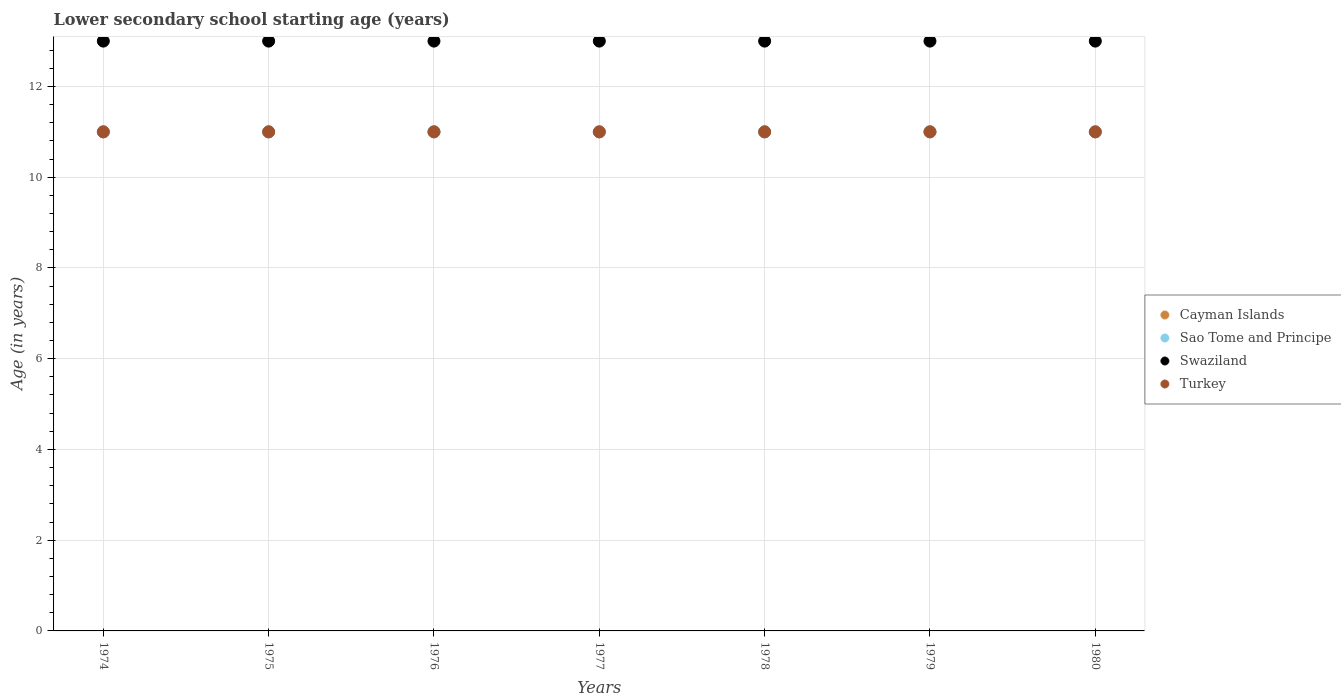Across all years, what is the maximum lower secondary school starting age of children in Swaziland?
Your answer should be very brief. 13. Across all years, what is the minimum lower secondary school starting age of children in Swaziland?
Keep it short and to the point. 13. In which year was the lower secondary school starting age of children in Turkey maximum?
Offer a very short reply. 1974. In which year was the lower secondary school starting age of children in Sao Tome and Principe minimum?
Offer a very short reply. 1974. What is the total lower secondary school starting age of children in Swaziland in the graph?
Make the answer very short. 91. In the year 1979, what is the difference between the lower secondary school starting age of children in Cayman Islands and lower secondary school starting age of children in Turkey?
Provide a short and direct response. 0. Is the lower secondary school starting age of children in Swaziland in 1974 less than that in 1977?
Provide a short and direct response. No. What is the difference between the highest and the second highest lower secondary school starting age of children in Sao Tome and Principe?
Provide a succinct answer. 0. In how many years, is the lower secondary school starting age of children in Swaziland greater than the average lower secondary school starting age of children in Swaziland taken over all years?
Your answer should be compact. 0. Does the lower secondary school starting age of children in Cayman Islands monotonically increase over the years?
Provide a short and direct response. No. Is the lower secondary school starting age of children in Turkey strictly greater than the lower secondary school starting age of children in Swaziland over the years?
Keep it short and to the point. No. Is the lower secondary school starting age of children in Sao Tome and Principe strictly less than the lower secondary school starting age of children in Cayman Islands over the years?
Make the answer very short. No. Does the graph contain any zero values?
Your answer should be compact. No. Does the graph contain grids?
Your answer should be compact. Yes. Where does the legend appear in the graph?
Offer a very short reply. Center right. How many legend labels are there?
Provide a short and direct response. 4. What is the title of the graph?
Keep it short and to the point. Lower secondary school starting age (years). What is the label or title of the Y-axis?
Offer a terse response. Age (in years). What is the Age (in years) of Cayman Islands in 1974?
Make the answer very short. 11. What is the Age (in years) in Sao Tome and Principe in 1974?
Provide a short and direct response. 11. What is the Age (in years) in Swaziland in 1974?
Your answer should be very brief. 13. What is the Age (in years) in Cayman Islands in 1975?
Ensure brevity in your answer.  11. What is the Age (in years) of Sao Tome and Principe in 1975?
Your response must be concise. 11. What is the Age (in years) of Sao Tome and Principe in 1976?
Ensure brevity in your answer.  11. What is the Age (in years) in Turkey in 1976?
Provide a short and direct response. 11. What is the Age (in years) of Cayman Islands in 1977?
Keep it short and to the point. 11. What is the Age (in years) of Turkey in 1977?
Offer a terse response. 11. What is the Age (in years) of Turkey in 1978?
Your answer should be very brief. 11. What is the Age (in years) in Cayman Islands in 1979?
Provide a short and direct response. 11. What is the Age (in years) of Sao Tome and Principe in 1979?
Your answer should be very brief. 11. What is the Age (in years) in Cayman Islands in 1980?
Ensure brevity in your answer.  11. What is the Age (in years) in Turkey in 1980?
Keep it short and to the point. 11. Across all years, what is the maximum Age (in years) in Cayman Islands?
Make the answer very short. 11. Across all years, what is the maximum Age (in years) in Turkey?
Provide a short and direct response. 11. Across all years, what is the minimum Age (in years) in Cayman Islands?
Keep it short and to the point. 11. Across all years, what is the minimum Age (in years) in Turkey?
Ensure brevity in your answer.  11. What is the total Age (in years) of Swaziland in the graph?
Provide a short and direct response. 91. What is the difference between the Age (in years) of Cayman Islands in 1974 and that in 1975?
Offer a very short reply. 0. What is the difference between the Age (in years) in Swaziland in 1974 and that in 1975?
Provide a succinct answer. 0. What is the difference between the Age (in years) in Turkey in 1974 and that in 1975?
Keep it short and to the point. 0. What is the difference between the Age (in years) in Sao Tome and Principe in 1974 and that in 1977?
Keep it short and to the point. 0. What is the difference between the Age (in years) in Swaziland in 1974 and that in 1977?
Provide a succinct answer. 0. What is the difference between the Age (in years) in Turkey in 1974 and that in 1977?
Your answer should be very brief. 0. What is the difference between the Age (in years) in Cayman Islands in 1974 and that in 1978?
Your answer should be compact. 0. What is the difference between the Age (in years) of Sao Tome and Principe in 1974 and that in 1978?
Ensure brevity in your answer.  0. What is the difference between the Age (in years) in Turkey in 1974 and that in 1978?
Make the answer very short. 0. What is the difference between the Age (in years) of Cayman Islands in 1974 and that in 1979?
Your response must be concise. 0. What is the difference between the Age (in years) of Sao Tome and Principe in 1974 and that in 1979?
Offer a very short reply. 0. What is the difference between the Age (in years) in Swaziland in 1974 and that in 1979?
Give a very brief answer. 0. What is the difference between the Age (in years) of Turkey in 1974 and that in 1979?
Provide a succinct answer. 0. What is the difference between the Age (in years) of Cayman Islands in 1974 and that in 1980?
Provide a succinct answer. 0. What is the difference between the Age (in years) of Swaziland in 1974 and that in 1980?
Offer a very short reply. 0. What is the difference between the Age (in years) in Turkey in 1974 and that in 1980?
Offer a terse response. 0. What is the difference between the Age (in years) in Cayman Islands in 1975 and that in 1976?
Give a very brief answer. 0. What is the difference between the Age (in years) of Sao Tome and Principe in 1975 and that in 1976?
Offer a very short reply. 0. What is the difference between the Age (in years) of Cayman Islands in 1975 and that in 1977?
Provide a succinct answer. 0. What is the difference between the Age (in years) in Sao Tome and Principe in 1975 and that in 1977?
Make the answer very short. 0. What is the difference between the Age (in years) in Swaziland in 1975 and that in 1977?
Offer a terse response. 0. What is the difference between the Age (in years) of Turkey in 1975 and that in 1977?
Ensure brevity in your answer.  0. What is the difference between the Age (in years) in Cayman Islands in 1975 and that in 1978?
Make the answer very short. 0. What is the difference between the Age (in years) of Sao Tome and Principe in 1975 and that in 1978?
Your answer should be compact. 0. What is the difference between the Age (in years) of Swaziland in 1975 and that in 1978?
Make the answer very short. 0. What is the difference between the Age (in years) in Turkey in 1975 and that in 1979?
Ensure brevity in your answer.  0. What is the difference between the Age (in years) in Cayman Islands in 1976 and that in 1977?
Keep it short and to the point. 0. What is the difference between the Age (in years) of Sao Tome and Principe in 1976 and that in 1977?
Your answer should be very brief. 0. What is the difference between the Age (in years) in Swaziland in 1976 and that in 1977?
Your answer should be compact. 0. What is the difference between the Age (in years) in Turkey in 1976 and that in 1978?
Offer a very short reply. 0. What is the difference between the Age (in years) in Swaziland in 1976 and that in 1979?
Provide a succinct answer. 0. What is the difference between the Age (in years) in Sao Tome and Principe in 1976 and that in 1980?
Your answer should be compact. 0. What is the difference between the Age (in years) in Turkey in 1976 and that in 1980?
Your response must be concise. 0. What is the difference between the Age (in years) of Sao Tome and Principe in 1977 and that in 1978?
Give a very brief answer. 0. What is the difference between the Age (in years) in Swaziland in 1977 and that in 1978?
Provide a short and direct response. 0. What is the difference between the Age (in years) in Cayman Islands in 1977 and that in 1980?
Offer a terse response. 0. What is the difference between the Age (in years) of Swaziland in 1977 and that in 1980?
Provide a succinct answer. 0. What is the difference between the Age (in years) in Sao Tome and Principe in 1978 and that in 1979?
Offer a terse response. 0. What is the difference between the Age (in years) in Swaziland in 1978 and that in 1980?
Offer a terse response. 0. What is the difference between the Age (in years) in Cayman Islands in 1979 and that in 1980?
Keep it short and to the point. 0. What is the difference between the Age (in years) of Sao Tome and Principe in 1979 and that in 1980?
Your answer should be compact. 0. What is the difference between the Age (in years) of Cayman Islands in 1974 and the Age (in years) of Swaziland in 1975?
Offer a terse response. -2. What is the difference between the Age (in years) in Cayman Islands in 1974 and the Age (in years) in Turkey in 1975?
Provide a short and direct response. 0. What is the difference between the Age (in years) in Swaziland in 1974 and the Age (in years) in Turkey in 1975?
Provide a succinct answer. 2. What is the difference between the Age (in years) of Cayman Islands in 1974 and the Age (in years) of Sao Tome and Principe in 1976?
Provide a short and direct response. 0. What is the difference between the Age (in years) of Cayman Islands in 1974 and the Age (in years) of Swaziland in 1976?
Give a very brief answer. -2. What is the difference between the Age (in years) of Sao Tome and Principe in 1974 and the Age (in years) of Turkey in 1976?
Offer a very short reply. 0. What is the difference between the Age (in years) of Swaziland in 1974 and the Age (in years) of Turkey in 1976?
Provide a succinct answer. 2. What is the difference between the Age (in years) in Cayman Islands in 1974 and the Age (in years) in Sao Tome and Principe in 1977?
Your answer should be compact. 0. What is the difference between the Age (in years) in Cayman Islands in 1974 and the Age (in years) in Turkey in 1977?
Offer a very short reply. 0. What is the difference between the Age (in years) of Sao Tome and Principe in 1974 and the Age (in years) of Swaziland in 1977?
Your answer should be very brief. -2. What is the difference between the Age (in years) of Sao Tome and Principe in 1974 and the Age (in years) of Turkey in 1977?
Your answer should be compact. 0. What is the difference between the Age (in years) in Swaziland in 1974 and the Age (in years) in Turkey in 1977?
Make the answer very short. 2. What is the difference between the Age (in years) of Cayman Islands in 1974 and the Age (in years) of Sao Tome and Principe in 1978?
Provide a short and direct response. 0. What is the difference between the Age (in years) in Cayman Islands in 1974 and the Age (in years) in Turkey in 1978?
Your response must be concise. 0. What is the difference between the Age (in years) of Sao Tome and Principe in 1974 and the Age (in years) of Swaziland in 1978?
Offer a very short reply. -2. What is the difference between the Age (in years) of Swaziland in 1974 and the Age (in years) of Turkey in 1978?
Ensure brevity in your answer.  2. What is the difference between the Age (in years) of Cayman Islands in 1974 and the Age (in years) of Sao Tome and Principe in 1979?
Keep it short and to the point. 0. What is the difference between the Age (in years) of Sao Tome and Principe in 1974 and the Age (in years) of Swaziland in 1979?
Ensure brevity in your answer.  -2. What is the difference between the Age (in years) of Sao Tome and Principe in 1974 and the Age (in years) of Turkey in 1979?
Offer a very short reply. 0. What is the difference between the Age (in years) of Swaziland in 1974 and the Age (in years) of Turkey in 1979?
Keep it short and to the point. 2. What is the difference between the Age (in years) in Sao Tome and Principe in 1974 and the Age (in years) in Turkey in 1980?
Offer a very short reply. 0. What is the difference between the Age (in years) in Swaziland in 1974 and the Age (in years) in Turkey in 1980?
Make the answer very short. 2. What is the difference between the Age (in years) of Cayman Islands in 1975 and the Age (in years) of Swaziland in 1976?
Give a very brief answer. -2. What is the difference between the Age (in years) of Sao Tome and Principe in 1975 and the Age (in years) of Swaziland in 1976?
Provide a short and direct response. -2. What is the difference between the Age (in years) of Sao Tome and Principe in 1975 and the Age (in years) of Turkey in 1976?
Your response must be concise. 0. What is the difference between the Age (in years) of Swaziland in 1975 and the Age (in years) of Turkey in 1977?
Give a very brief answer. 2. What is the difference between the Age (in years) in Cayman Islands in 1975 and the Age (in years) in Sao Tome and Principe in 1978?
Your response must be concise. 0. What is the difference between the Age (in years) of Cayman Islands in 1975 and the Age (in years) of Turkey in 1978?
Provide a succinct answer. 0. What is the difference between the Age (in years) in Sao Tome and Principe in 1975 and the Age (in years) in Swaziland in 1978?
Ensure brevity in your answer.  -2. What is the difference between the Age (in years) in Sao Tome and Principe in 1975 and the Age (in years) in Swaziland in 1979?
Make the answer very short. -2. What is the difference between the Age (in years) in Sao Tome and Principe in 1975 and the Age (in years) in Turkey in 1980?
Make the answer very short. 0. What is the difference between the Age (in years) in Cayman Islands in 1976 and the Age (in years) in Swaziland in 1977?
Make the answer very short. -2. What is the difference between the Age (in years) of Cayman Islands in 1976 and the Age (in years) of Turkey in 1977?
Make the answer very short. 0. What is the difference between the Age (in years) in Sao Tome and Principe in 1976 and the Age (in years) in Swaziland in 1977?
Your answer should be very brief. -2. What is the difference between the Age (in years) in Cayman Islands in 1976 and the Age (in years) in Sao Tome and Principe in 1978?
Provide a short and direct response. 0. What is the difference between the Age (in years) of Sao Tome and Principe in 1976 and the Age (in years) of Turkey in 1978?
Offer a terse response. 0. What is the difference between the Age (in years) of Cayman Islands in 1976 and the Age (in years) of Swaziland in 1979?
Provide a succinct answer. -2. What is the difference between the Age (in years) of Cayman Islands in 1976 and the Age (in years) of Turkey in 1979?
Provide a succinct answer. 0. What is the difference between the Age (in years) of Swaziland in 1976 and the Age (in years) of Turkey in 1979?
Provide a succinct answer. 2. What is the difference between the Age (in years) in Cayman Islands in 1976 and the Age (in years) in Swaziland in 1980?
Your answer should be compact. -2. What is the difference between the Age (in years) in Cayman Islands in 1976 and the Age (in years) in Turkey in 1980?
Ensure brevity in your answer.  0. What is the difference between the Age (in years) of Sao Tome and Principe in 1976 and the Age (in years) of Turkey in 1980?
Your response must be concise. 0. What is the difference between the Age (in years) in Cayman Islands in 1977 and the Age (in years) in Sao Tome and Principe in 1978?
Give a very brief answer. 0. What is the difference between the Age (in years) of Cayman Islands in 1977 and the Age (in years) of Turkey in 1978?
Give a very brief answer. 0. What is the difference between the Age (in years) of Sao Tome and Principe in 1977 and the Age (in years) of Swaziland in 1978?
Make the answer very short. -2. What is the difference between the Age (in years) in Cayman Islands in 1977 and the Age (in years) in Sao Tome and Principe in 1979?
Give a very brief answer. 0. What is the difference between the Age (in years) of Cayman Islands in 1977 and the Age (in years) of Swaziland in 1979?
Your answer should be very brief. -2. What is the difference between the Age (in years) of Sao Tome and Principe in 1977 and the Age (in years) of Turkey in 1979?
Your response must be concise. 0. What is the difference between the Age (in years) in Swaziland in 1977 and the Age (in years) in Turkey in 1979?
Your answer should be compact. 2. What is the difference between the Age (in years) in Cayman Islands in 1977 and the Age (in years) in Swaziland in 1980?
Provide a succinct answer. -2. What is the difference between the Age (in years) of Cayman Islands in 1977 and the Age (in years) of Turkey in 1980?
Ensure brevity in your answer.  0. What is the difference between the Age (in years) of Sao Tome and Principe in 1977 and the Age (in years) of Swaziland in 1980?
Provide a short and direct response. -2. What is the difference between the Age (in years) in Sao Tome and Principe in 1977 and the Age (in years) in Turkey in 1980?
Provide a short and direct response. 0. What is the difference between the Age (in years) in Swaziland in 1977 and the Age (in years) in Turkey in 1980?
Ensure brevity in your answer.  2. What is the difference between the Age (in years) of Cayman Islands in 1978 and the Age (in years) of Swaziland in 1979?
Your answer should be compact. -2. What is the difference between the Age (in years) in Cayman Islands in 1978 and the Age (in years) in Turkey in 1979?
Your response must be concise. 0. What is the difference between the Age (in years) in Swaziland in 1978 and the Age (in years) in Turkey in 1979?
Provide a succinct answer. 2. What is the difference between the Age (in years) of Sao Tome and Principe in 1978 and the Age (in years) of Swaziland in 1980?
Your response must be concise. -2. What is the difference between the Age (in years) of Sao Tome and Principe in 1978 and the Age (in years) of Turkey in 1980?
Your answer should be very brief. 0. What is the difference between the Age (in years) in Cayman Islands in 1979 and the Age (in years) in Swaziland in 1980?
Offer a terse response. -2. What is the difference between the Age (in years) of Cayman Islands in 1979 and the Age (in years) of Turkey in 1980?
Keep it short and to the point. 0. What is the difference between the Age (in years) of Sao Tome and Principe in 1979 and the Age (in years) of Swaziland in 1980?
Provide a short and direct response. -2. What is the difference between the Age (in years) in Sao Tome and Principe in 1979 and the Age (in years) in Turkey in 1980?
Ensure brevity in your answer.  0. What is the difference between the Age (in years) of Swaziland in 1979 and the Age (in years) of Turkey in 1980?
Your answer should be compact. 2. What is the average Age (in years) in Swaziland per year?
Your answer should be very brief. 13. What is the average Age (in years) of Turkey per year?
Make the answer very short. 11. In the year 1974, what is the difference between the Age (in years) of Cayman Islands and Age (in years) of Turkey?
Your answer should be very brief. 0. In the year 1974, what is the difference between the Age (in years) of Sao Tome and Principe and Age (in years) of Swaziland?
Provide a short and direct response. -2. In the year 1974, what is the difference between the Age (in years) in Sao Tome and Principe and Age (in years) in Turkey?
Make the answer very short. 0. In the year 1975, what is the difference between the Age (in years) of Cayman Islands and Age (in years) of Sao Tome and Principe?
Offer a terse response. 0. In the year 1975, what is the difference between the Age (in years) of Cayman Islands and Age (in years) of Swaziland?
Keep it short and to the point. -2. In the year 1975, what is the difference between the Age (in years) in Sao Tome and Principe and Age (in years) in Swaziland?
Keep it short and to the point. -2. In the year 1975, what is the difference between the Age (in years) in Sao Tome and Principe and Age (in years) in Turkey?
Provide a succinct answer. 0. In the year 1975, what is the difference between the Age (in years) in Swaziland and Age (in years) in Turkey?
Give a very brief answer. 2. In the year 1976, what is the difference between the Age (in years) of Cayman Islands and Age (in years) of Sao Tome and Principe?
Offer a terse response. 0. In the year 1976, what is the difference between the Age (in years) in Cayman Islands and Age (in years) in Swaziland?
Keep it short and to the point. -2. In the year 1976, what is the difference between the Age (in years) of Sao Tome and Principe and Age (in years) of Swaziland?
Your response must be concise. -2. In the year 1977, what is the difference between the Age (in years) of Cayman Islands and Age (in years) of Sao Tome and Principe?
Offer a terse response. 0. In the year 1977, what is the difference between the Age (in years) of Cayman Islands and Age (in years) of Swaziland?
Keep it short and to the point. -2. In the year 1977, what is the difference between the Age (in years) in Cayman Islands and Age (in years) in Turkey?
Offer a terse response. 0. In the year 1977, what is the difference between the Age (in years) of Sao Tome and Principe and Age (in years) of Swaziland?
Your response must be concise. -2. In the year 1977, what is the difference between the Age (in years) in Sao Tome and Principe and Age (in years) in Turkey?
Ensure brevity in your answer.  0. In the year 1978, what is the difference between the Age (in years) of Cayman Islands and Age (in years) of Turkey?
Your answer should be very brief. 0. In the year 1978, what is the difference between the Age (in years) in Sao Tome and Principe and Age (in years) in Swaziland?
Ensure brevity in your answer.  -2. In the year 1978, what is the difference between the Age (in years) in Swaziland and Age (in years) in Turkey?
Offer a very short reply. 2. In the year 1979, what is the difference between the Age (in years) of Cayman Islands and Age (in years) of Swaziland?
Provide a succinct answer. -2. In the year 1979, what is the difference between the Age (in years) of Cayman Islands and Age (in years) of Turkey?
Offer a very short reply. 0. In the year 1979, what is the difference between the Age (in years) in Sao Tome and Principe and Age (in years) in Swaziland?
Keep it short and to the point. -2. In the year 1979, what is the difference between the Age (in years) of Sao Tome and Principe and Age (in years) of Turkey?
Give a very brief answer. 0. In the year 1979, what is the difference between the Age (in years) of Swaziland and Age (in years) of Turkey?
Provide a short and direct response. 2. In the year 1980, what is the difference between the Age (in years) of Cayman Islands and Age (in years) of Swaziland?
Your response must be concise. -2. In the year 1980, what is the difference between the Age (in years) of Cayman Islands and Age (in years) of Turkey?
Provide a succinct answer. 0. In the year 1980, what is the difference between the Age (in years) of Sao Tome and Principe and Age (in years) of Swaziland?
Your answer should be compact. -2. In the year 1980, what is the difference between the Age (in years) of Sao Tome and Principe and Age (in years) of Turkey?
Provide a succinct answer. 0. What is the ratio of the Age (in years) in Cayman Islands in 1974 to that in 1975?
Keep it short and to the point. 1. What is the ratio of the Age (in years) in Sao Tome and Principe in 1974 to that in 1975?
Provide a succinct answer. 1. What is the ratio of the Age (in years) of Swaziland in 1974 to that in 1975?
Your answer should be compact. 1. What is the ratio of the Age (in years) of Turkey in 1974 to that in 1975?
Make the answer very short. 1. What is the ratio of the Age (in years) of Cayman Islands in 1974 to that in 1977?
Your answer should be very brief. 1. What is the ratio of the Age (in years) of Swaziland in 1974 to that in 1977?
Offer a very short reply. 1. What is the ratio of the Age (in years) of Turkey in 1974 to that in 1978?
Your answer should be compact. 1. What is the ratio of the Age (in years) of Cayman Islands in 1974 to that in 1979?
Keep it short and to the point. 1. What is the ratio of the Age (in years) of Sao Tome and Principe in 1974 to that in 1979?
Ensure brevity in your answer.  1. What is the ratio of the Age (in years) of Turkey in 1974 to that in 1979?
Keep it short and to the point. 1. What is the ratio of the Age (in years) in Swaziland in 1974 to that in 1980?
Keep it short and to the point. 1. What is the ratio of the Age (in years) of Sao Tome and Principe in 1975 to that in 1976?
Make the answer very short. 1. What is the ratio of the Age (in years) of Turkey in 1975 to that in 1976?
Ensure brevity in your answer.  1. What is the ratio of the Age (in years) in Cayman Islands in 1975 to that in 1977?
Ensure brevity in your answer.  1. What is the ratio of the Age (in years) of Sao Tome and Principe in 1975 to that in 1977?
Provide a short and direct response. 1. What is the ratio of the Age (in years) in Swaziland in 1975 to that in 1977?
Give a very brief answer. 1. What is the ratio of the Age (in years) of Turkey in 1975 to that in 1977?
Provide a short and direct response. 1. What is the ratio of the Age (in years) in Turkey in 1975 to that in 1978?
Ensure brevity in your answer.  1. What is the ratio of the Age (in years) of Turkey in 1975 to that in 1979?
Offer a very short reply. 1. What is the ratio of the Age (in years) of Swaziland in 1975 to that in 1980?
Keep it short and to the point. 1. What is the ratio of the Age (in years) in Cayman Islands in 1976 to that in 1977?
Your response must be concise. 1. What is the ratio of the Age (in years) in Turkey in 1976 to that in 1977?
Your answer should be very brief. 1. What is the ratio of the Age (in years) in Swaziland in 1976 to that in 1978?
Your answer should be very brief. 1. What is the ratio of the Age (in years) of Cayman Islands in 1976 to that in 1979?
Provide a succinct answer. 1. What is the ratio of the Age (in years) of Turkey in 1976 to that in 1979?
Provide a succinct answer. 1. What is the ratio of the Age (in years) in Cayman Islands in 1976 to that in 1980?
Keep it short and to the point. 1. What is the ratio of the Age (in years) of Sao Tome and Principe in 1976 to that in 1980?
Provide a succinct answer. 1. What is the ratio of the Age (in years) in Swaziland in 1976 to that in 1980?
Provide a short and direct response. 1. What is the ratio of the Age (in years) in Turkey in 1976 to that in 1980?
Make the answer very short. 1. What is the ratio of the Age (in years) in Cayman Islands in 1977 to that in 1978?
Your answer should be very brief. 1. What is the ratio of the Age (in years) of Swaziland in 1977 to that in 1978?
Provide a succinct answer. 1. What is the ratio of the Age (in years) in Turkey in 1977 to that in 1978?
Provide a succinct answer. 1. What is the ratio of the Age (in years) in Cayman Islands in 1977 to that in 1980?
Your answer should be very brief. 1. What is the ratio of the Age (in years) in Turkey in 1977 to that in 1980?
Your answer should be very brief. 1. What is the ratio of the Age (in years) of Cayman Islands in 1978 to that in 1979?
Your response must be concise. 1. What is the ratio of the Age (in years) of Swaziland in 1978 to that in 1980?
Your answer should be very brief. 1. What is the ratio of the Age (in years) in Cayman Islands in 1979 to that in 1980?
Make the answer very short. 1. What is the ratio of the Age (in years) of Sao Tome and Principe in 1979 to that in 1980?
Make the answer very short. 1. What is the difference between the highest and the second highest Age (in years) of Cayman Islands?
Provide a succinct answer. 0. What is the difference between the highest and the second highest Age (in years) of Swaziland?
Ensure brevity in your answer.  0. What is the difference between the highest and the second highest Age (in years) of Turkey?
Keep it short and to the point. 0. What is the difference between the highest and the lowest Age (in years) of Cayman Islands?
Your answer should be very brief. 0. What is the difference between the highest and the lowest Age (in years) of Sao Tome and Principe?
Offer a terse response. 0. What is the difference between the highest and the lowest Age (in years) of Swaziland?
Offer a very short reply. 0. What is the difference between the highest and the lowest Age (in years) in Turkey?
Your response must be concise. 0. 